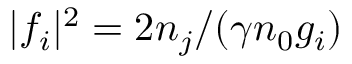Convert formula to latex. <formula><loc_0><loc_0><loc_500><loc_500>| f _ { i } | ^ { 2 } = 2 n _ { j } / ( \gamma n _ { 0 } g _ { i } )</formula> 